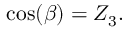<formula> <loc_0><loc_0><loc_500><loc_500>\cos ( \beta ) = Z _ { 3 } .</formula> 